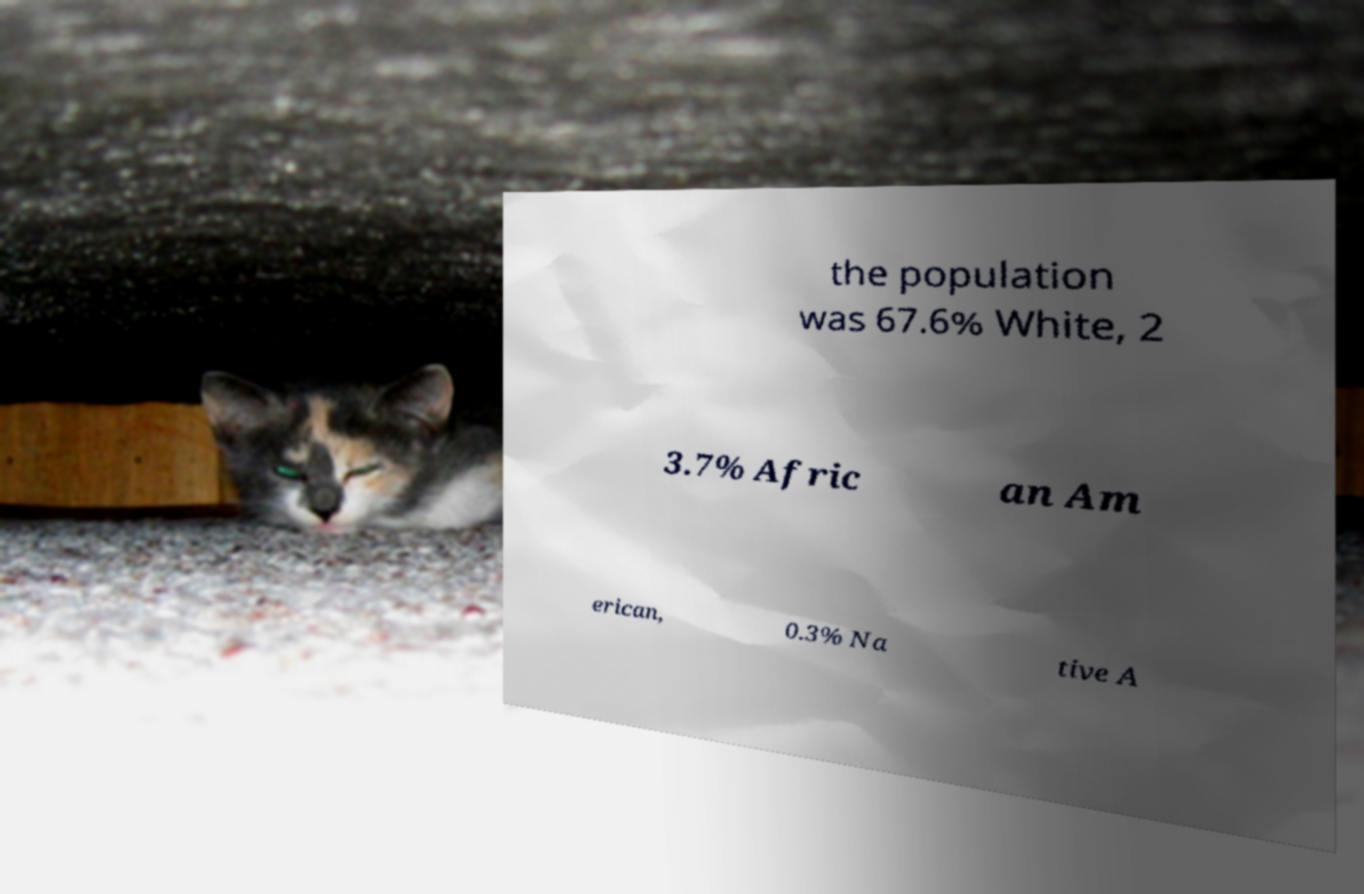Please read and relay the text visible in this image. What does it say? the population was 67.6% White, 2 3.7% Afric an Am erican, 0.3% Na tive A 